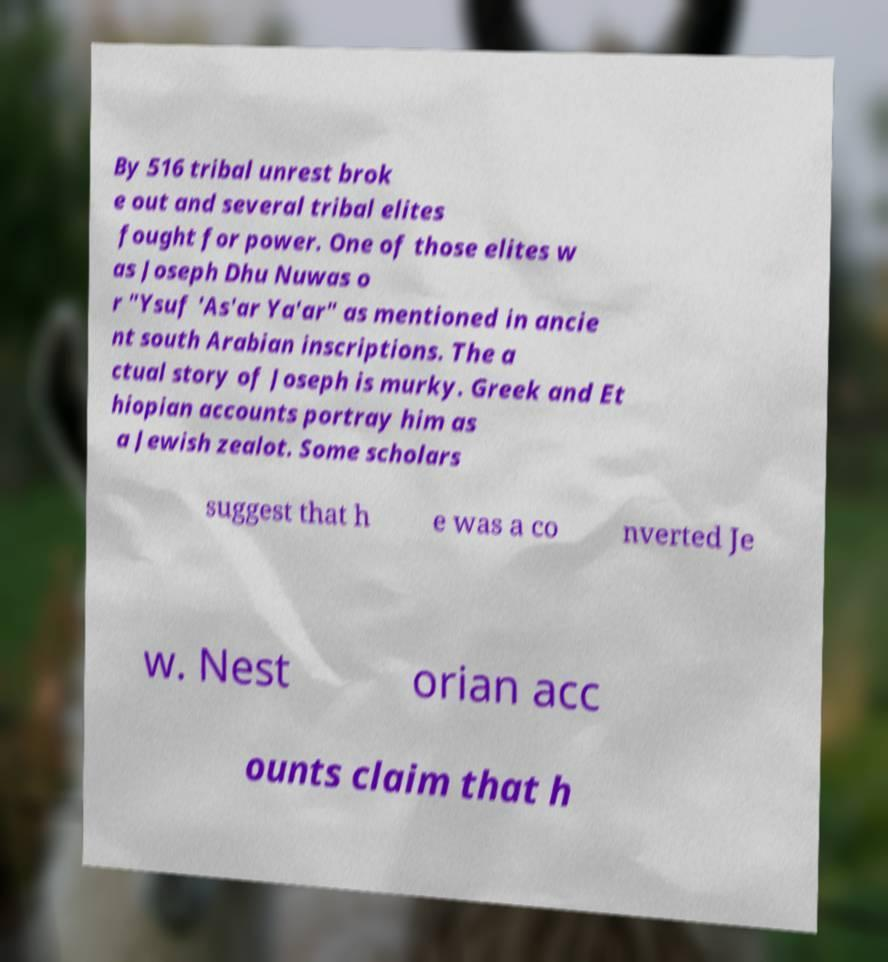Can you read and provide the text displayed in the image?This photo seems to have some interesting text. Can you extract and type it out for me? By 516 tribal unrest brok e out and several tribal elites fought for power. One of those elites w as Joseph Dhu Nuwas o r "Ysuf 'As'ar Ya'ar" as mentioned in ancie nt south Arabian inscriptions. The a ctual story of Joseph is murky. Greek and Et hiopian accounts portray him as a Jewish zealot. Some scholars suggest that h e was a co nverted Je w. Nest orian acc ounts claim that h 